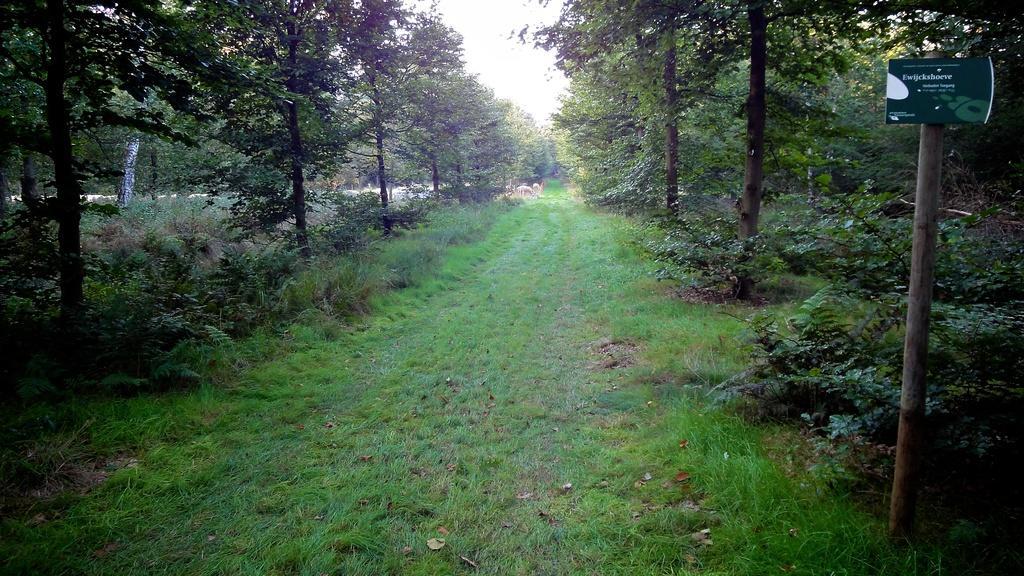In one or two sentences, can you explain what this image depicts? There is a grass. On both sides of this path, there are trees, plants and grass on the ground. In the background, there are animals, trees and there is sky. 